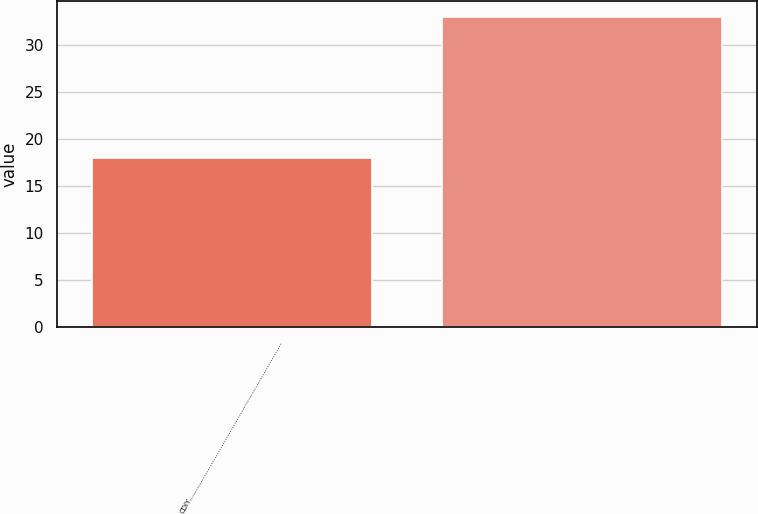<chart> <loc_0><loc_0><loc_500><loc_500><bar_chart><fcel>CDIY……………………………………………………………………<fcel>Unnamed: 1<nl><fcel>18<fcel>33<nl></chart> 